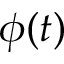Convert formula to latex. <formula><loc_0><loc_0><loc_500><loc_500>\phi ( t )</formula> 